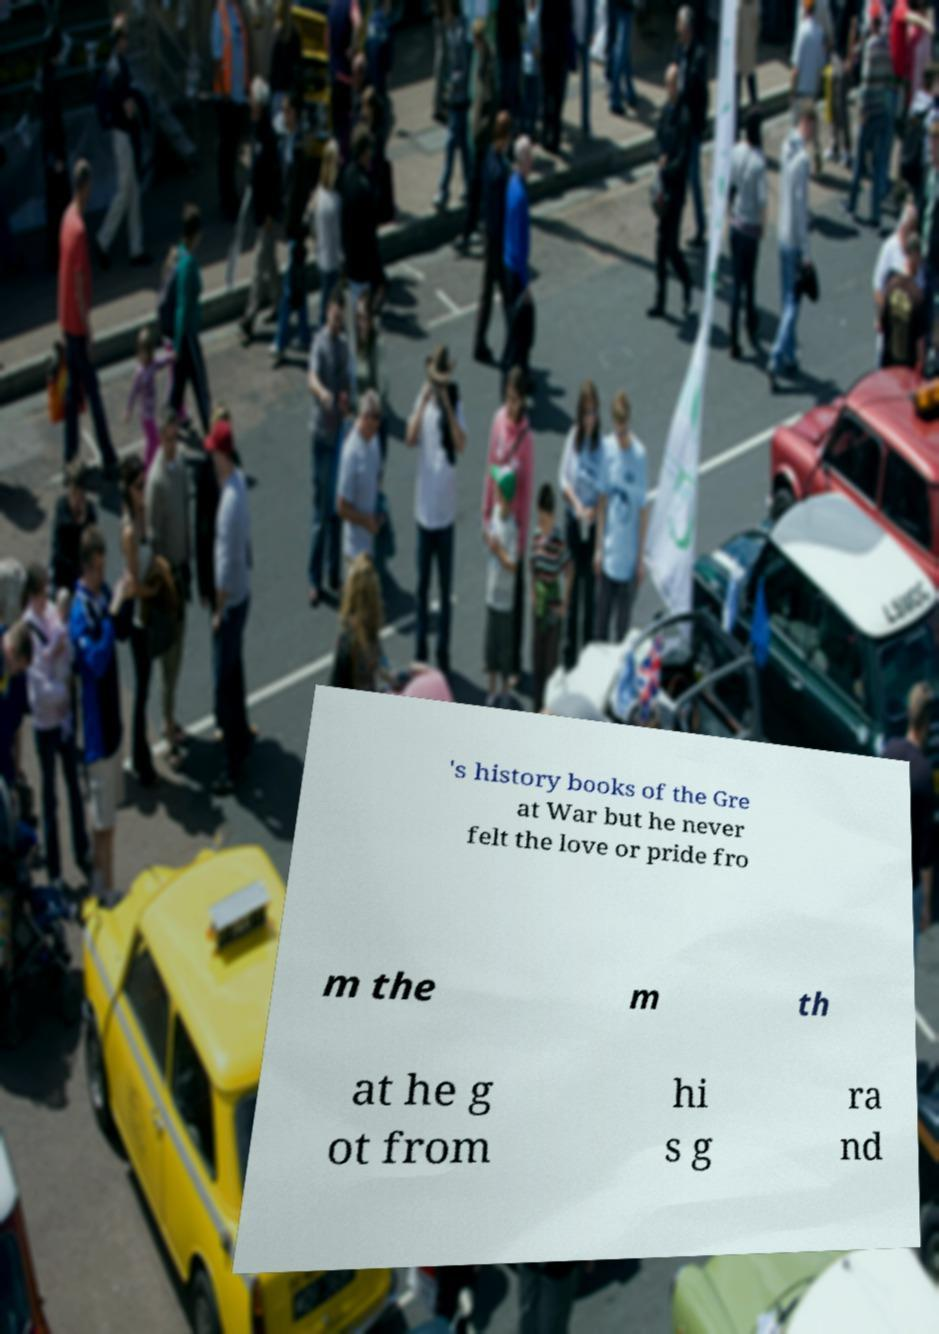I need the written content from this picture converted into text. Can you do that? 's history books of the Gre at War but he never felt the love or pride fro m the m th at he g ot from hi s g ra nd 